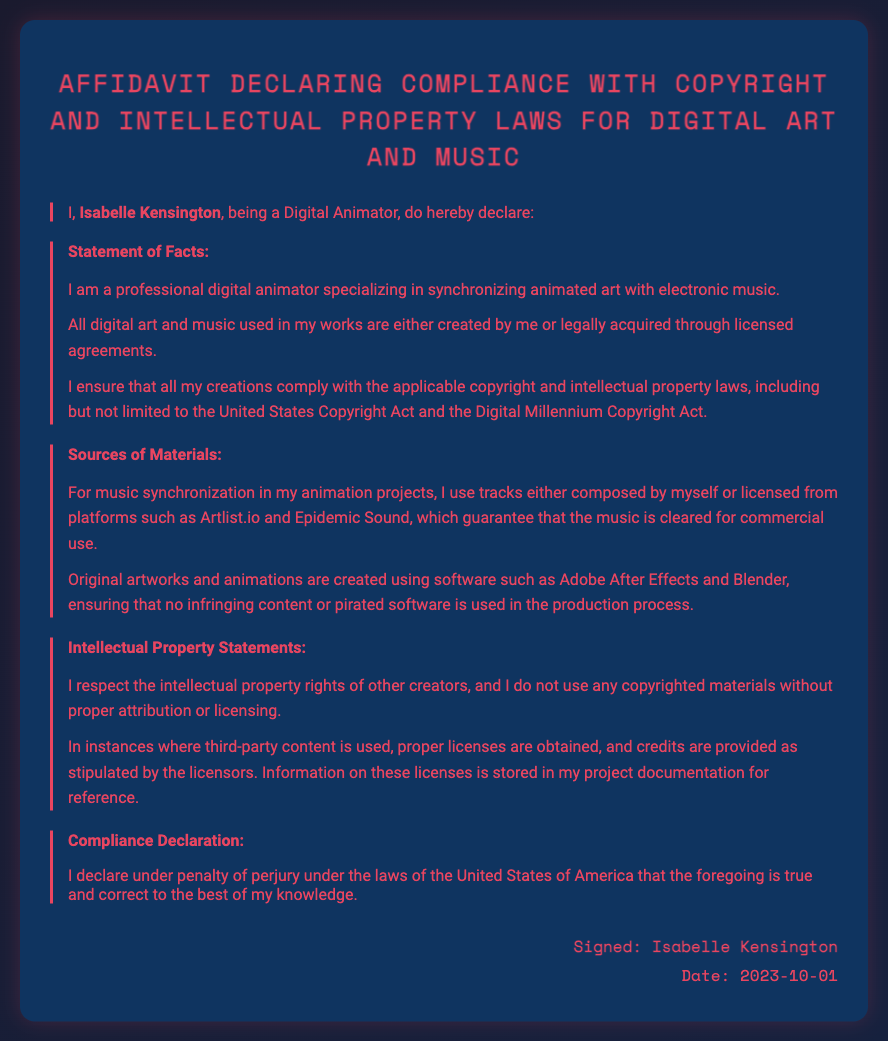What is the name of the declarant? The name of the declarant is mentioned in the first statement of the document.
Answer: Isabelle Kensington What is the profession of Isabelle Kensington? The profession of the declarant is provided at the beginning of the document.
Answer: Digital Animator What date was the affidavit signed? The date is mentioned in the signature section of the document.
Answer: 2023-10-01 Which two platforms are mentioned for music licensing? The platforms are listed in the section about sources of materials used in the projects.
Answer: Artlist.io and Epidemic Sound What software is used for creating original artworks? The relevant section provides specific software names used in the creation process.
Answer: Adobe After Effects and Blender What is the compliance declaration statement about? The declaration reiterates the authenticity of the statements made under legal accountability regarding copyright compliance.
Answer: True and correct to the best of my knowledge How does Isabelle Kensington ensure respect for intellectual property rights? The document outlines her approach toward third-party content usage and licensing.
Answer: Proper licenses are obtained, and credits are provided 